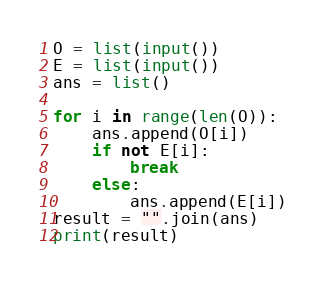<code> <loc_0><loc_0><loc_500><loc_500><_Python_>O = list(input())
E = list(input())
ans = list()
 
for i in range(len(O)):
    ans.append(O[i])
    if not E[i]:
        break
    else:
        ans.append(E[i])
result = "".join(ans)
print(result)</code> 